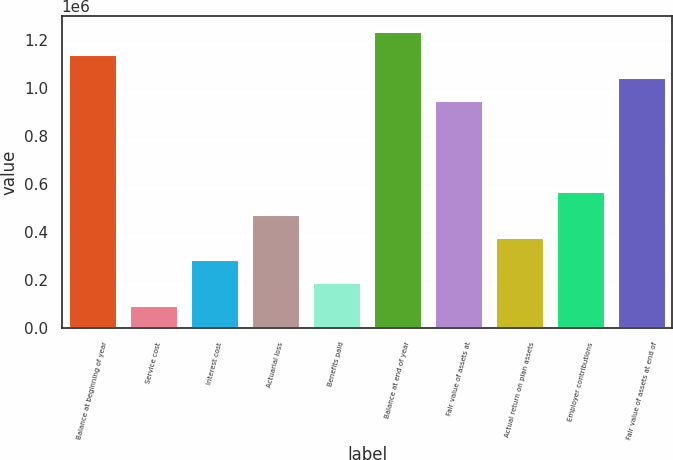Convert chart. <chart><loc_0><loc_0><loc_500><loc_500><bar_chart><fcel>Balance at beginning of year<fcel>Service cost<fcel>Interest cost<fcel>Actuarial loss<fcel>Benefits paid<fcel>Balance at end of year<fcel>Fair value of assets at<fcel>Actual return on plan assets<fcel>Employer contributions<fcel>Fair value of assets at end of<nl><fcel>1.14058e+06<fcel>95673.3<fcel>285656<fcel>475638<fcel>190665<fcel>1.23557e+06<fcel>950595<fcel>380647<fcel>570630<fcel>1.04559e+06<nl></chart> 